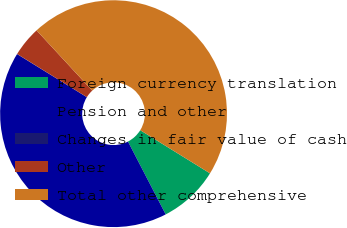Convert chart to OTSL. <chart><loc_0><loc_0><loc_500><loc_500><pie_chart><fcel>Foreign currency translation<fcel>Pension and other<fcel>Changes in fair value of cash<fcel>Other<fcel>Total other comprehensive<nl><fcel>8.58%<fcel>41.41%<fcel>0.02%<fcel>4.3%<fcel>45.69%<nl></chart> 